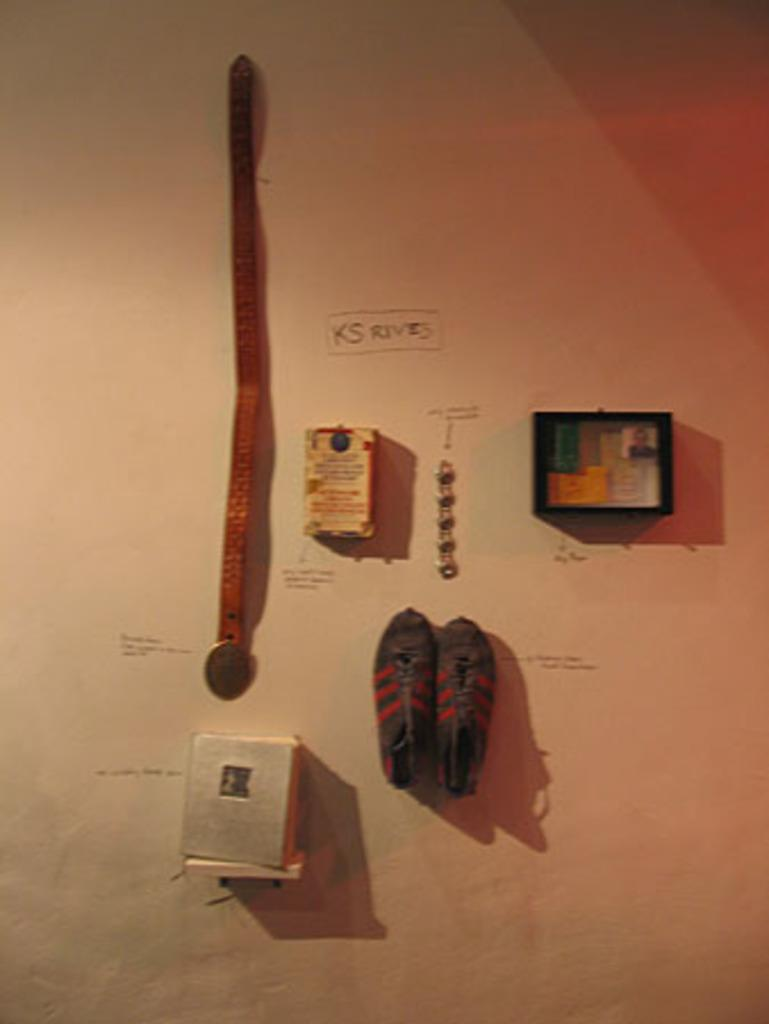What is the main object in the image? There is a box in the image. What other items can be seen in the image? There are shoes, a frame, and a belt in the image. What is the color of the surface on which the items are placed? All the mentioned items are placed on a white color surface. Can you describe the picture hanging on the wing in the image? There is no picture or wing present in the image. 